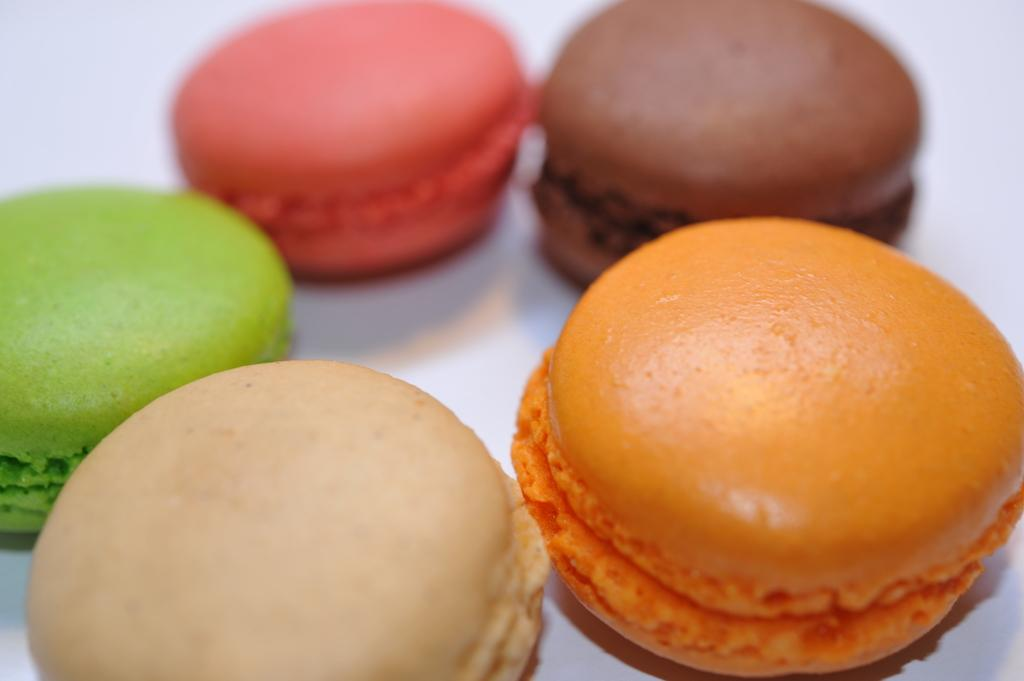What type of food is present in the image? There are macarons in the image. How many different colors can be seen on the macarons? The macarons have different colors. What is the color of the surface on which the macarons are placed? The surface on which the macarons are placed is white. How many cacti can be seen in the image? There are no cacti present in the image. What is the height of the sky in the image? The image does not depict a sky, so it is not possible to determine its height. 